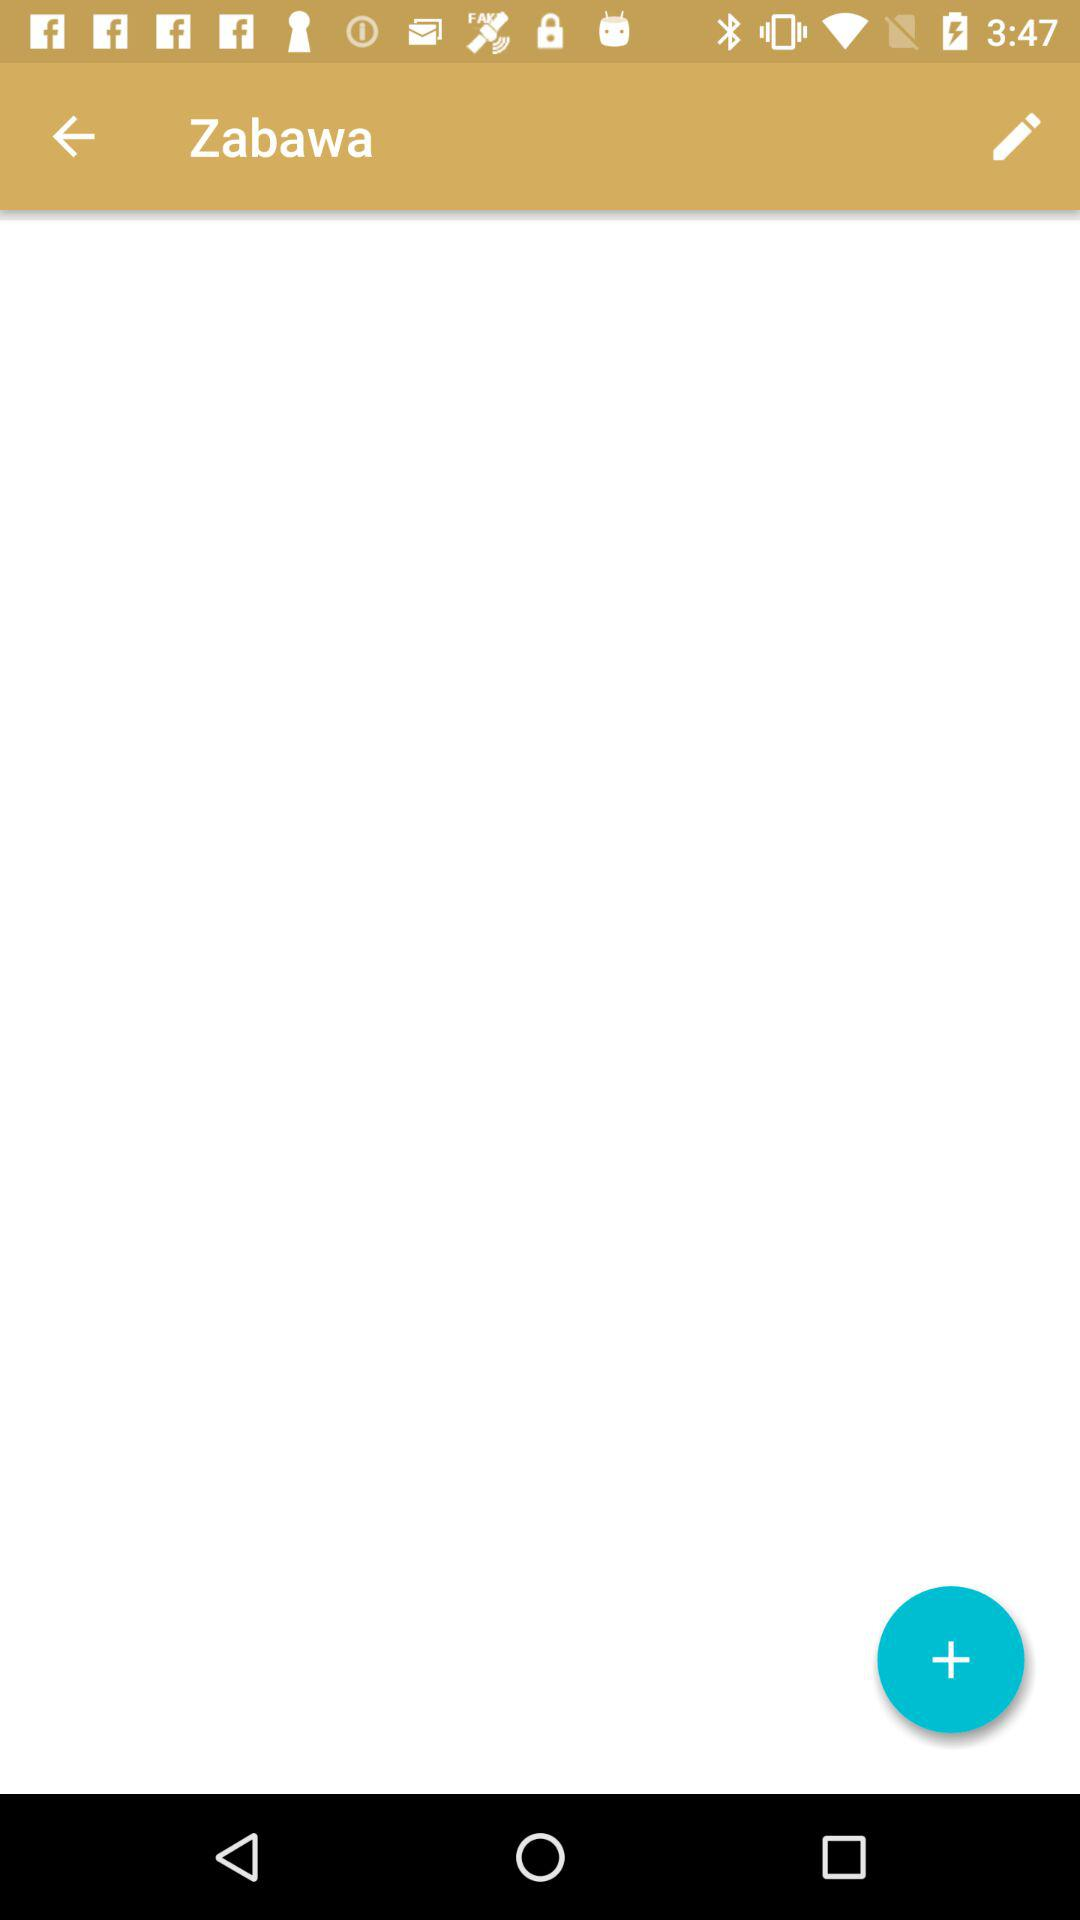What is the user name? The user name is Zabawa. 